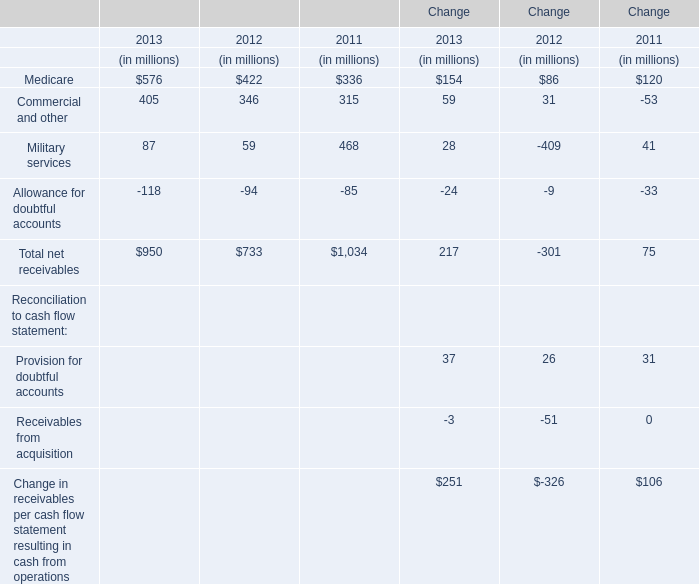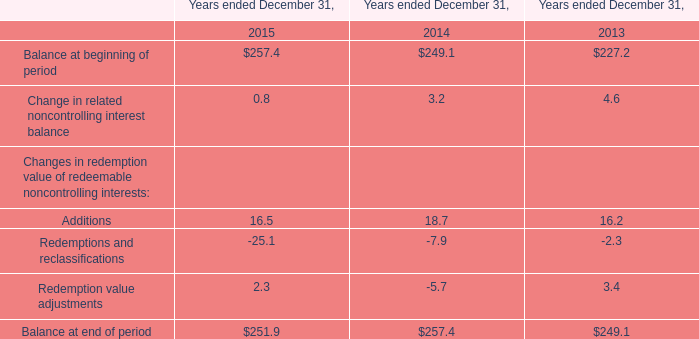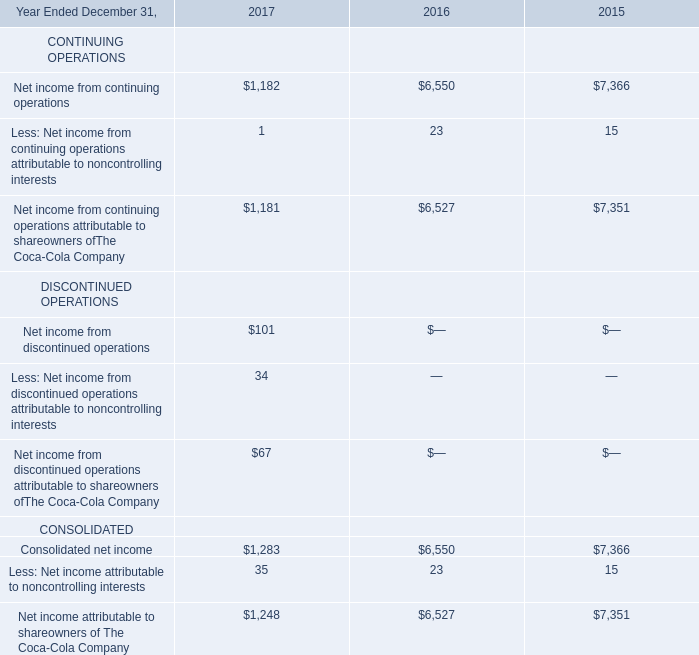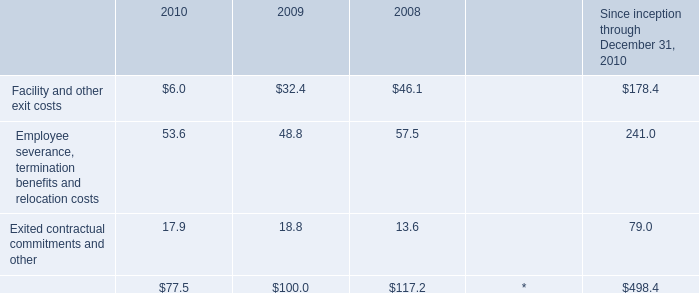What's the total value of all 2013 that are smaller than 100 in 2013? (in million) 
Computations: (87 - 118)
Answer: -31.0. 